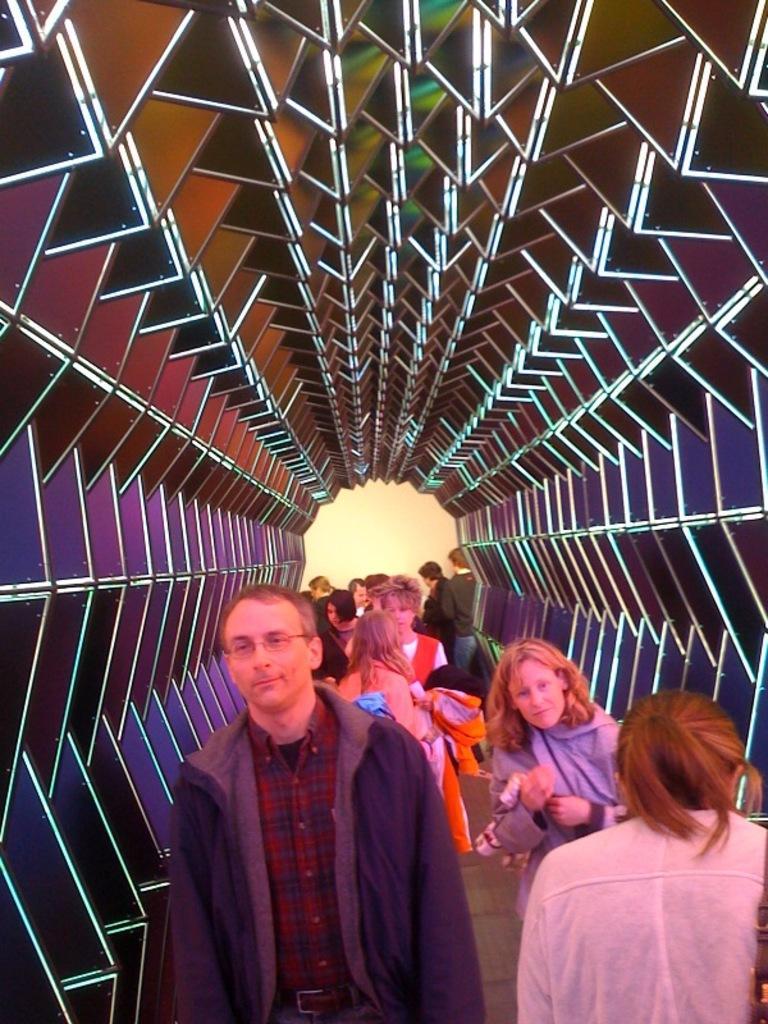Could you give a brief overview of what you see in this image? In this image I can see few people are wearing different color dresses and the background is in multi color. 